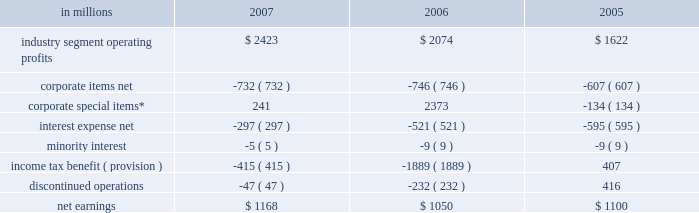Item 7 .
Management 2019s discussion and analysis of financial condition and results of operations executive summary international paper 2019s operating results in 2007 bene- fited from significantly higher paper and packaging price realizations .
Sales volumes were slightly high- er , with growth in overseas markets partially offset by lower volumes in north america as we continued to balance our production with our customers 2019 demand .
Operationally , our pulp and paper and containerboard mills ran very well in 2007 .
However , input costs for wood , energy and transportation costs were all well above 2006 levels .
In our forest products business , earnings decreased 31% ( 31 % ) reflect- ing a sharp decline in harvest income and a smaller drop in forestland and real estate sales , both reflect- ing our forestland divestitures in 2006 .
Interest expense decreased over 40% ( 40 % ) , principally due to lower debt balances and interest rates from debt repayments and refinancings .
Looking forward to the first quarter of 2008 , we expect demand for north american printing papers and packaging to remain steady .
However , if the economic downturn in 2008 is greater than expected , this could have a negative impact on sales volumes and earnings .
Some slight increases in paper and packaging price realizations are expected as we implement our announced price increases .
However , first quarter earnings will reflect increased planned maintenance expenses and continued escalation of wood , energy and transportation costs .
As a result , excluding the impact of projected reduced earnings from land sales and the addition of equity earnings contributions from our recent investment in ilim holding s.a .
In russia , we expect 2008 first-quarter earnings to be lower than in the 2007 fourth quarter .
Results of operations industry segment operating profits are used by inter- national paper 2019s management to measure the earn- ings performance of its businesses .
Management believes that this measure allows a better under- standing of trends in costs , operating efficiencies , prices and volumes .
Industry segment operating profits are defined as earnings before taxes and minority interest , interest expense , corporate items and corporate special items .
Industry segment oper- ating profits are defined by the securities and exchange commission as a non-gaap financial measure , and are not gaap alternatives to net earn- ings or any other operating measure prescribed by accounting principles generally accepted in the united states .
International paper operates in six segments : print- ing papers , industrial packaging , consumer pack- aging , distribution , forest products , and specialty businesses and other .
The table shows the components of net earnings for each of the last three years : in millions 2007 2006 2005 .
* corporate special items include restructuring and other charg- es , net ( gains ) losses on sales and impairments of businesses , gains on transformation plan forestland sales , goodwill impairment charges , insurance recoveries and reversals of reserves no longer required .
Industry segment operating profits of $ 2.4 billion were $ 349 million higher in 2007 than in 2006 due principally to the benefits from higher average price realizations ( $ 461 million ) , the net impact of cost reduction initiatives , improved operating perform- ance and a more favorable mix of products sold ( $ 304 million ) , higher sales volumes ( $ 17 million ) , lower special item costs ( $ 115 million ) and other items ( $ 4 million ) .
These benefits more than offset the impacts of higher energy , raw material and freight costs ( $ 205 million ) , higher costs for planned mill maintenance outages ( $ 48 million ) , lower earn- ings from land sales ( $ 101 million ) , costs at the pensacola mill associated with the conversion of a machine to the production of linerboard ( $ 52 million ) and reduced earnings due to net acquisitions and divestitures ( $ 146 million ) .
Segment operating profit ( in millions ) $ 2074 ( $ 205 ) ( $ 48 ) $ 17 ( $ 244 ) $ 2423$ 4 ( $ 52 ) ( $ 101 ) $ 461 $ 1000 $ 1500 $ 2000 $ 2500 $ 3000 .
What was the percentage change in industry segment operating profits from 2006 to 2007? 
Computations: ((2423 - 2074) / 2074)
Answer: 0.16827. Item 7 .
Management 2019s discussion and analysis of financial condition and results of operations executive summary international paper 2019s operating results in 2007 bene- fited from significantly higher paper and packaging price realizations .
Sales volumes were slightly high- er , with growth in overseas markets partially offset by lower volumes in north america as we continued to balance our production with our customers 2019 demand .
Operationally , our pulp and paper and containerboard mills ran very well in 2007 .
However , input costs for wood , energy and transportation costs were all well above 2006 levels .
In our forest products business , earnings decreased 31% ( 31 % ) reflect- ing a sharp decline in harvest income and a smaller drop in forestland and real estate sales , both reflect- ing our forestland divestitures in 2006 .
Interest expense decreased over 40% ( 40 % ) , principally due to lower debt balances and interest rates from debt repayments and refinancings .
Looking forward to the first quarter of 2008 , we expect demand for north american printing papers and packaging to remain steady .
However , if the economic downturn in 2008 is greater than expected , this could have a negative impact on sales volumes and earnings .
Some slight increases in paper and packaging price realizations are expected as we implement our announced price increases .
However , first quarter earnings will reflect increased planned maintenance expenses and continued escalation of wood , energy and transportation costs .
As a result , excluding the impact of projected reduced earnings from land sales and the addition of equity earnings contributions from our recent investment in ilim holding s.a .
In russia , we expect 2008 first-quarter earnings to be lower than in the 2007 fourth quarter .
Results of operations industry segment operating profits are used by inter- national paper 2019s management to measure the earn- ings performance of its businesses .
Management believes that this measure allows a better under- standing of trends in costs , operating efficiencies , prices and volumes .
Industry segment operating profits are defined as earnings before taxes and minority interest , interest expense , corporate items and corporate special items .
Industry segment oper- ating profits are defined by the securities and exchange commission as a non-gaap financial measure , and are not gaap alternatives to net earn- ings or any other operating measure prescribed by accounting principles generally accepted in the united states .
International paper operates in six segments : print- ing papers , industrial packaging , consumer pack- aging , distribution , forest products , and specialty businesses and other .
The table shows the components of net earnings for each of the last three years : in millions 2007 2006 2005 .
* corporate special items include restructuring and other charg- es , net ( gains ) losses on sales and impairments of businesses , gains on transformation plan forestland sales , goodwill impairment charges , insurance recoveries and reversals of reserves no longer required .
Industry segment operating profits of $ 2.4 billion were $ 349 million higher in 2007 than in 2006 due principally to the benefits from higher average price realizations ( $ 461 million ) , the net impact of cost reduction initiatives , improved operating perform- ance and a more favorable mix of products sold ( $ 304 million ) , higher sales volumes ( $ 17 million ) , lower special item costs ( $ 115 million ) and other items ( $ 4 million ) .
These benefits more than offset the impacts of higher energy , raw material and freight costs ( $ 205 million ) , higher costs for planned mill maintenance outages ( $ 48 million ) , lower earn- ings from land sales ( $ 101 million ) , costs at the pensacola mill associated with the conversion of a machine to the production of linerboard ( $ 52 million ) and reduced earnings due to net acquisitions and divestitures ( $ 146 million ) .
Segment operating profit ( in millions ) $ 2074 ( $ 205 ) ( $ 48 ) $ 17 ( $ 244 ) $ 2423$ 4 ( $ 52 ) ( $ 101 ) $ 461 $ 1000 $ 1500 $ 2000 $ 2500 $ 3000 .
In 2007 what was the percentage change in the industry segment operating profits from 2006? 
Computations: (349 / (2.4 - 349))
Answer: -1.00692. 